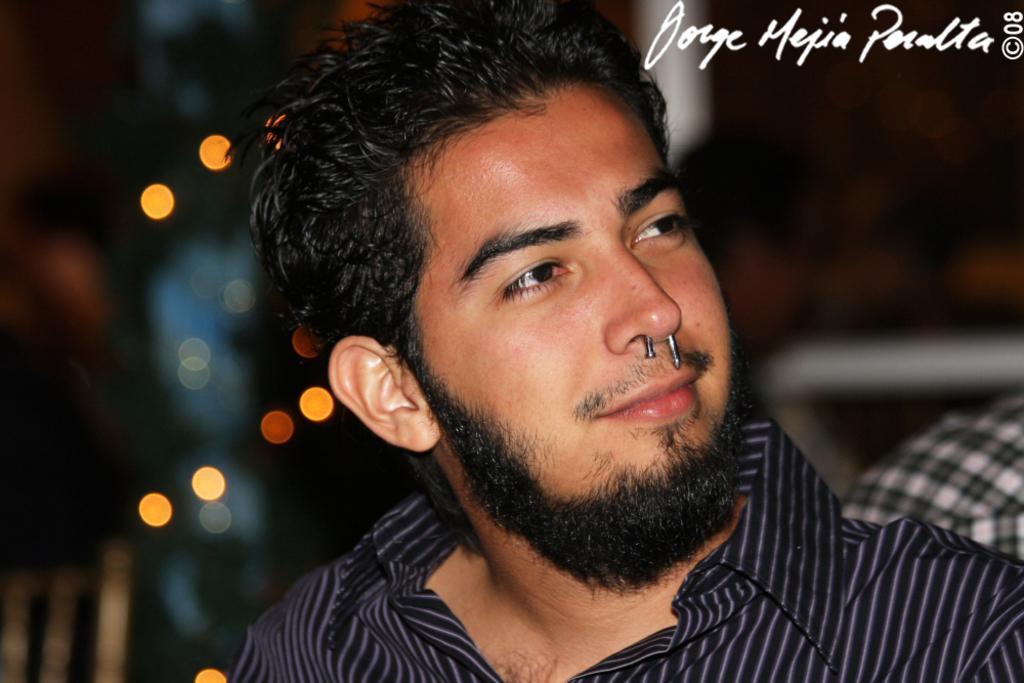How would you summarize this image in a sentence or two? In this picture we can see a person smiling. There are lights and a few things visible in the background. Background is blurry. We can see a watermark, some text and numbers in the top right. 